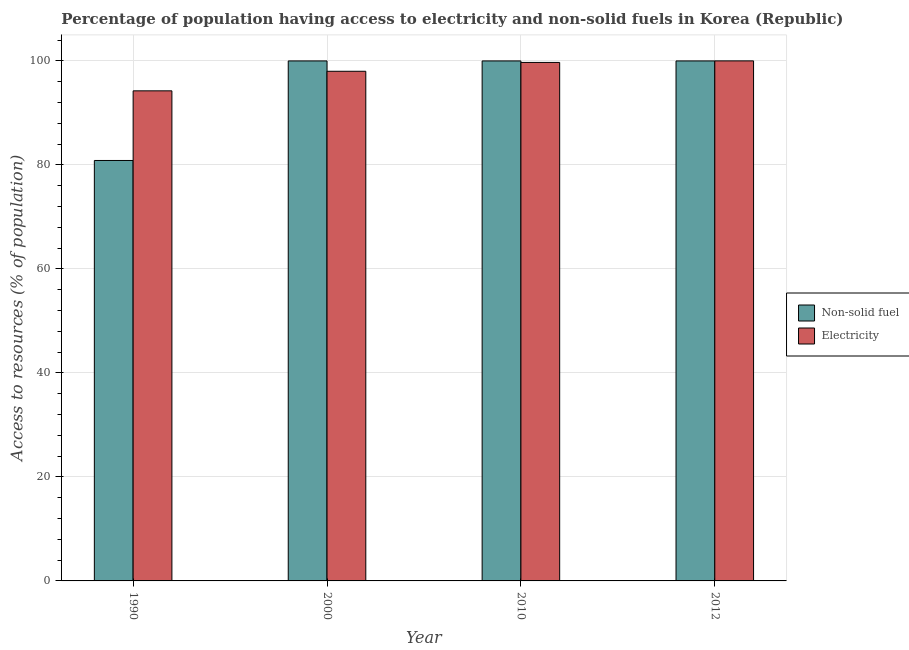Are the number of bars per tick equal to the number of legend labels?
Your response must be concise. Yes. How many bars are there on the 4th tick from the right?
Offer a very short reply. 2. What is the label of the 1st group of bars from the left?
Ensure brevity in your answer.  1990. What is the percentage of population having access to electricity in 2010?
Keep it short and to the point. 99.7. Across all years, what is the maximum percentage of population having access to non-solid fuel?
Your answer should be very brief. 99.99. Across all years, what is the minimum percentage of population having access to non-solid fuel?
Offer a terse response. 80.85. In which year was the percentage of population having access to non-solid fuel maximum?
Give a very brief answer. 2000. What is the total percentage of population having access to electricity in the graph?
Ensure brevity in your answer.  391.94. What is the difference between the percentage of population having access to non-solid fuel in 1990 and the percentage of population having access to electricity in 2012?
Your response must be concise. -19.14. What is the average percentage of population having access to electricity per year?
Your answer should be very brief. 97.98. In how many years, is the percentage of population having access to electricity greater than 64 %?
Make the answer very short. 4. What is the ratio of the percentage of population having access to non-solid fuel in 1990 to that in 2000?
Your answer should be compact. 0.81. Is the percentage of population having access to non-solid fuel in 2010 less than that in 2012?
Your answer should be very brief. No. What is the difference between the highest and the second highest percentage of population having access to electricity?
Provide a succinct answer. 0.3. What is the difference between the highest and the lowest percentage of population having access to electricity?
Your response must be concise. 5.76. Is the sum of the percentage of population having access to electricity in 1990 and 2000 greater than the maximum percentage of population having access to non-solid fuel across all years?
Make the answer very short. Yes. What does the 2nd bar from the left in 2012 represents?
Keep it short and to the point. Electricity. What does the 2nd bar from the right in 2000 represents?
Keep it short and to the point. Non-solid fuel. How many bars are there?
Provide a short and direct response. 8. Are all the bars in the graph horizontal?
Your response must be concise. No. Are the values on the major ticks of Y-axis written in scientific E-notation?
Keep it short and to the point. No. Does the graph contain any zero values?
Your answer should be very brief. No. Does the graph contain grids?
Your answer should be very brief. Yes. Where does the legend appear in the graph?
Your response must be concise. Center right. What is the title of the graph?
Offer a very short reply. Percentage of population having access to electricity and non-solid fuels in Korea (Republic). What is the label or title of the X-axis?
Ensure brevity in your answer.  Year. What is the label or title of the Y-axis?
Provide a short and direct response. Access to resources (% of population). What is the Access to resources (% of population) of Non-solid fuel in 1990?
Your answer should be compact. 80.85. What is the Access to resources (% of population) of Electricity in 1990?
Ensure brevity in your answer.  94.24. What is the Access to resources (% of population) of Non-solid fuel in 2000?
Your answer should be compact. 99.99. What is the Access to resources (% of population) of Non-solid fuel in 2010?
Your answer should be very brief. 99.99. What is the Access to resources (% of population) of Electricity in 2010?
Provide a short and direct response. 99.7. What is the Access to resources (% of population) of Non-solid fuel in 2012?
Offer a very short reply. 99.99. Across all years, what is the maximum Access to resources (% of population) in Non-solid fuel?
Your answer should be compact. 99.99. Across all years, what is the maximum Access to resources (% of population) in Electricity?
Offer a terse response. 100. Across all years, what is the minimum Access to resources (% of population) in Non-solid fuel?
Your answer should be compact. 80.85. Across all years, what is the minimum Access to resources (% of population) in Electricity?
Ensure brevity in your answer.  94.24. What is the total Access to resources (% of population) in Non-solid fuel in the graph?
Provide a succinct answer. 380.82. What is the total Access to resources (% of population) of Electricity in the graph?
Keep it short and to the point. 391.94. What is the difference between the Access to resources (% of population) of Non-solid fuel in 1990 and that in 2000?
Your answer should be compact. -19.14. What is the difference between the Access to resources (% of population) in Electricity in 1990 and that in 2000?
Offer a terse response. -3.76. What is the difference between the Access to resources (% of population) in Non-solid fuel in 1990 and that in 2010?
Your answer should be very brief. -19.14. What is the difference between the Access to resources (% of population) of Electricity in 1990 and that in 2010?
Your answer should be compact. -5.46. What is the difference between the Access to resources (% of population) of Non-solid fuel in 1990 and that in 2012?
Your response must be concise. -19.14. What is the difference between the Access to resources (% of population) of Electricity in 1990 and that in 2012?
Provide a short and direct response. -5.76. What is the difference between the Access to resources (% of population) of Non-solid fuel in 2000 and that in 2010?
Offer a very short reply. 0. What is the difference between the Access to resources (% of population) of Electricity in 2000 and that in 2012?
Make the answer very short. -2. What is the difference between the Access to resources (% of population) in Non-solid fuel in 1990 and the Access to resources (% of population) in Electricity in 2000?
Keep it short and to the point. -17.15. What is the difference between the Access to resources (% of population) in Non-solid fuel in 1990 and the Access to resources (% of population) in Electricity in 2010?
Provide a short and direct response. -18.85. What is the difference between the Access to resources (% of population) of Non-solid fuel in 1990 and the Access to resources (% of population) of Electricity in 2012?
Your answer should be very brief. -19.15. What is the difference between the Access to resources (% of population) of Non-solid fuel in 2000 and the Access to resources (% of population) of Electricity in 2010?
Offer a very short reply. 0.29. What is the difference between the Access to resources (% of population) in Non-solid fuel in 2000 and the Access to resources (% of population) in Electricity in 2012?
Keep it short and to the point. -0.01. What is the difference between the Access to resources (% of population) of Non-solid fuel in 2010 and the Access to resources (% of population) of Electricity in 2012?
Keep it short and to the point. -0.01. What is the average Access to resources (% of population) of Non-solid fuel per year?
Your answer should be compact. 95.2. What is the average Access to resources (% of population) of Electricity per year?
Make the answer very short. 97.98. In the year 1990, what is the difference between the Access to resources (% of population) of Non-solid fuel and Access to resources (% of population) of Electricity?
Keep it short and to the point. -13.39. In the year 2000, what is the difference between the Access to resources (% of population) of Non-solid fuel and Access to resources (% of population) of Electricity?
Offer a very short reply. 1.99. In the year 2010, what is the difference between the Access to resources (% of population) of Non-solid fuel and Access to resources (% of population) of Electricity?
Keep it short and to the point. 0.29. In the year 2012, what is the difference between the Access to resources (% of population) of Non-solid fuel and Access to resources (% of population) of Electricity?
Your response must be concise. -0.01. What is the ratio of the Access to resources (% of population) of Non-solid fuel in 1990 to that in 2000?
Make the answer very short. 0.81. What is the ratio of the Access to resources (% of population) in Electricity in 1990 to that in 2000?
Provide a succinct answer. 0.96. What is the ratio of the Access to resources (% of population) of Non-solid fuel in 1990 to that in 2010?
Offer a very short reply. 0.81. What is the ratio of the Access to resources (% of population) in Electricity in 1990 to that in 2010?
Your response must be concise. 0.95. What is the ratio of the Access to resources (% of population) of Non-solid fuel in 1990 to that in 2012?
Keep it short and to the point. 0.81. What is the ratio of the Access to resources (% of population) in Electricity in 1990 to that in 2012?
Offer a terse response. 0.94. What is the ratio of the Access to resources (% of population) of Electricity in 2000 to that in 2010?
Your answer should be compact. 0.98. What is the ratio of the Access to resources (% of population) of Non-solid fuel in 2010 to that in 2012?
Offer a terse response. 1. What is the ratio of the Access to resources (% of population) in Electricity in 2010 to that in 2012?
Your response must be concise. 1. What is the difference between the highest and the second highest Access to resources (% of population) of Non-solid fuel?
Your response must be concise. 0. What is the difference between the highest and the lowest Access to resources (% of population) of Non-solid fuel?
Provide a succinct answer. 19.14. What is the difference between the highest and the lowest Access to resources (% of population) in Electricity?
Give a very brief answer. 5.76. 